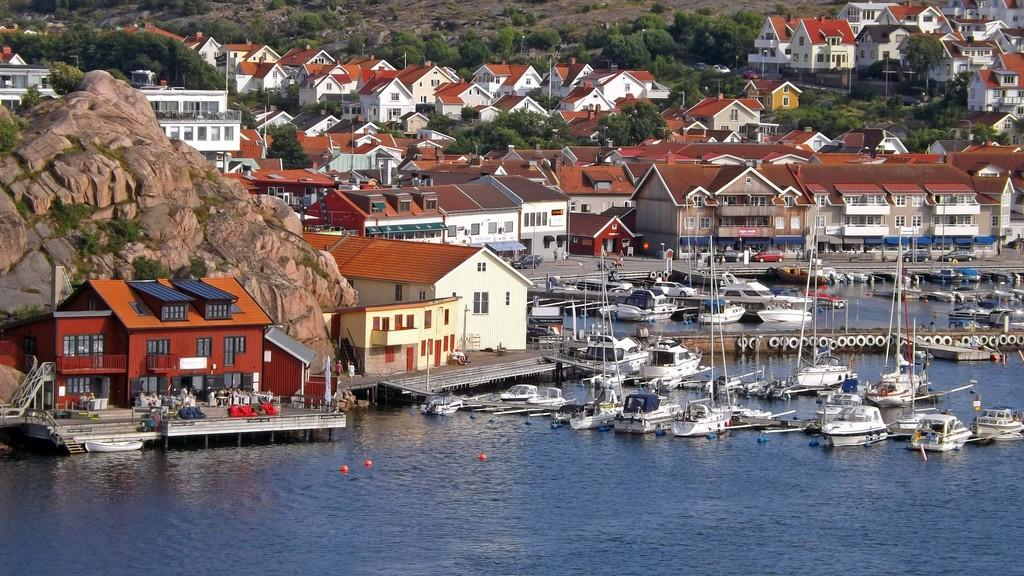What type of structures can be seen in the image? There are many houses in the image. What natural elements are present in the image? There are trees and hills in the image. What man-made objects can be seen in the image? There are vehicles and a road in the image. What is on the surface of the water in the image? There are boats on the surface of the water in the image. What safety feature is visible in the image? Safety rings are visible in the image. Can you tell me the color of the flower in the image? There is no flower present in the image. How many eyes can be seen on the hen in the image? There is no hen present in the image. 